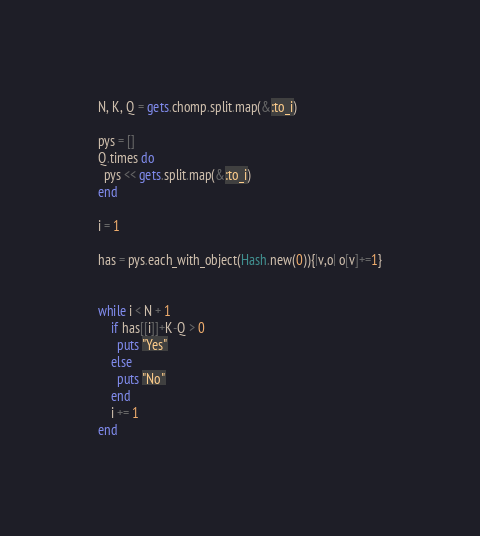<code> <loc_0><loc_0><loc_500><loc_500><_Ruby_>N, K, Q = gets.chomp.split.map(&:to_i)

pys = []
Q.times do
  pys << gets.split.map(&:to_i)
end

i = 1

has = pys.each_with_object(Hash.new(0)){|v,o| o[v]+=1}


while i < N + 1
	if has[[i]]+K-Q > 0
	  puts "Yes"
    else
      puts "No"
    end
    i += 1
end</code> 